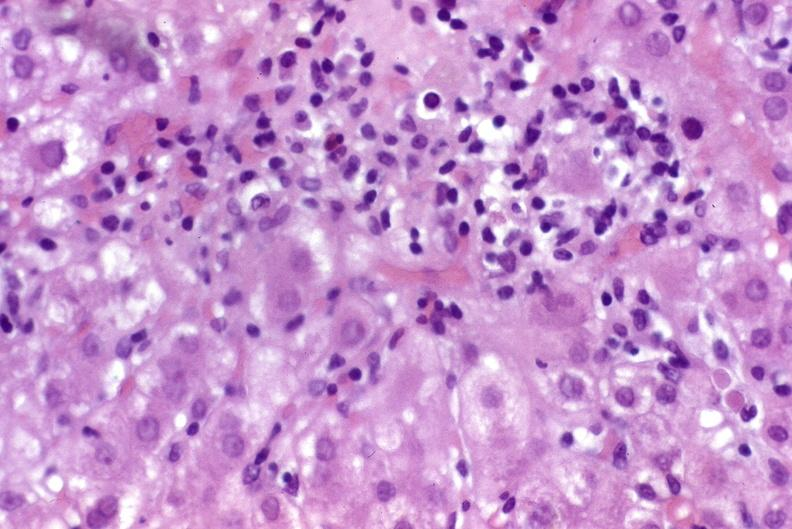s carcinoma superficial spreading present?
Answer the question using a single word or phrase. No 